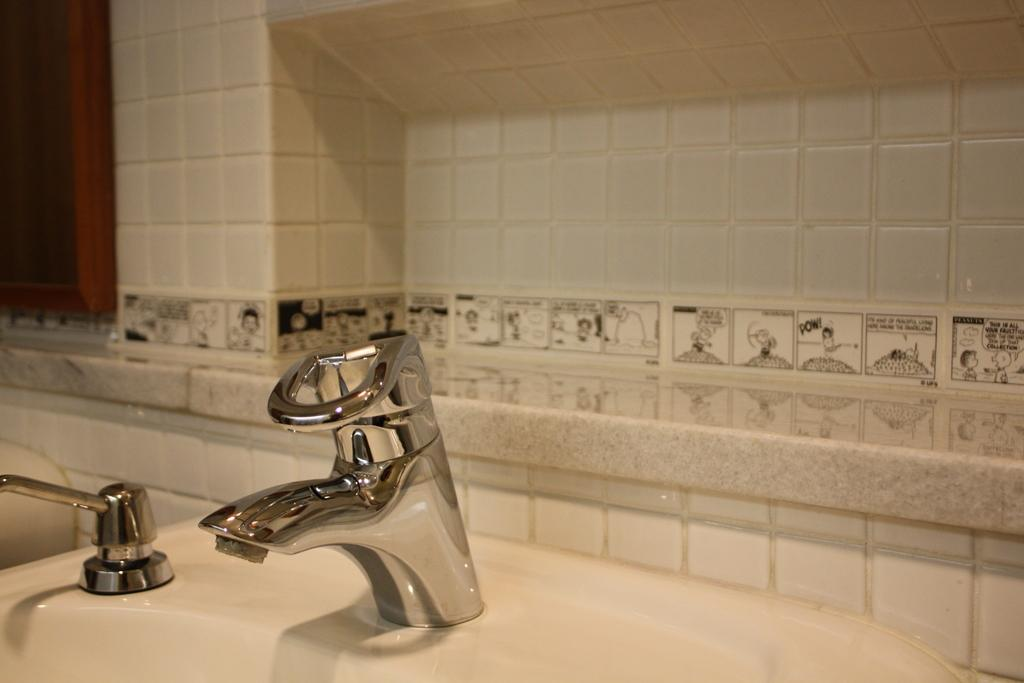What is on the sink in the image? There are tapes on the sink. What can be seen behind the taps? There is a window behind the taps. What type of wall does the window belong to? The window is on a tile wall. What story is being told by the garden outside the window? There is no garden visible in the image, and therefore no story can be told by it. How many rings are visible on the taps in the image? There is no mention of rings on the taps in the provided facts, so we cannot determine their presence or quantity. 